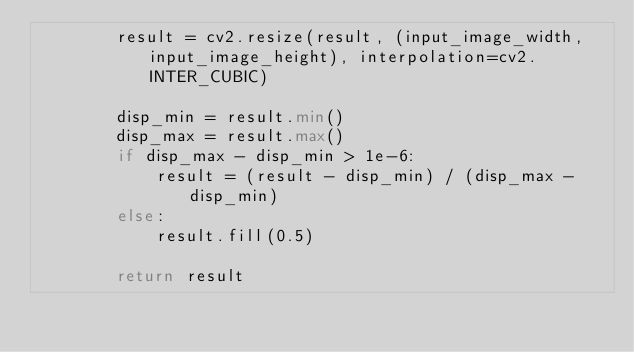<code> <loc_0><loc_0><loc_500><loc_500><_Python_>        result = cv2.resize(result, (input_image_width, input_image_height), interpolation=cv2.INTER_CUBIC)

        disp_min = result.min()
        disp_max = result.max()
        if disp_max - disp_min > 1e-6:
            result = (result - disp_min) / (disp_max - disp_min)
        else:
            result.fill(0.5)

        return result
</code> 